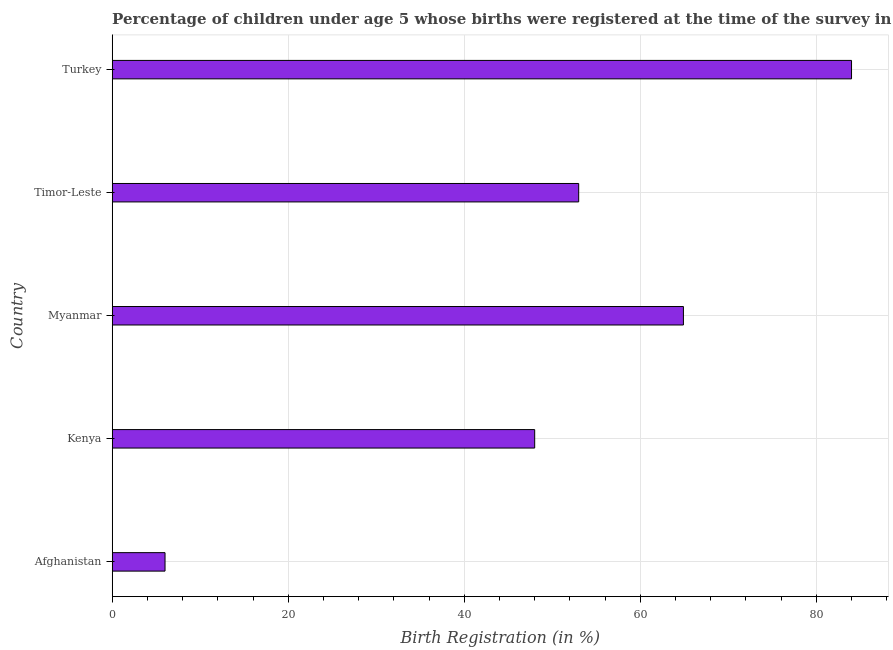Does the graph contain any zero values?
Keep it short and to the point. No. Does the graph contain grids?
Offer a terse response. Yes. What is the title of the graph?
Give a very brief answer. Percentage of children under age 5 whose births were registered at the time of the survey in 2003. What is the label or title of the X-axis?
Provide a short and direct response. Birth Registration (in %). What is the label or title of the Y-axis?
Provide a short and direct response. Country. What is the birth registration in Turkey?
Keep it short and to the point. 84. Across all countries, what is the minimum birth registration?
Provide a short and direct response. 6. In which country was the birth registration maximum?
Make the answer very short. Turkey. In which country was the birth registration minimum?
Your response must be concise. Afghanistan. What is the sum of the birth registration?
Offer a terse response. 255.9. What is the difference between the birth registration in Afghanistan and Myanmar?
Offer a terse response. -58.9. What is the average birth registration per country?
Make the answer very short. 51.18. What is the median birth registration?
Your answer should be compact. 53. What is the ratio of the birth registration in Kenya to that in Myanmar?
Your answer should be very brief. 0.74. Is the sum of the birth registration in Afghanistan and Timor-Leste greater than the maximum birth registration across all countries?
Your response must be concise. No. What is the difference between the highest and the lowest birth registration?
Give a very brief answer. 78. How many bars are there?
Make the answer very short. 5. What is the Birth Registration (in %) of Kenya?
Keep it short and to the point. 48. What is the Birth Registration (in %) of Myanmar?
Your answer should be compact. 64.9. What is the Birth Registration (in %) in Timor-Leste?
Ensure brevity in your answer.  53. What is the difference between the Birth Registration (in %) in Afghanistan and Kenya?
Offer a very short reply. -42. What is the difference between the Birth Registration (in %) in Afghanistan and Myanmar?
Offer a very short reply. -58.9. What is the difference between the Birth Registration (in %) in Afghanistan and Timor-Leste?
Offer a terse response. -47. What is the difference between the Birth Registration (in %) in Afghanistan and Turkey?
Offer a very short reply. -78. What is the difference between the Birth Registration (in %) in Kenya and Myanmar?
Offer a very short reply. -16.9. What is the difference between the Birth Registration (in %) in Kenya and Timor-Leste?
Your response must be concise. -5. What is the difference between the Birth Registration (in %) in Kenya and Turkey?
Your answer should be very brief. -36. What is the difference between the Birth Registration (in %) in Myanmar and Timor-Leste?
Provide a short and direct response. 11.9. What is the difference between the Birth Registration (in %) in Myanmar and Turkey?
Give a very brief answer. -19.1. What is the difference between the Birth Registration (in %) in Timor-Leste and Turkey?
Provide a short and direct response. -31. What is the ratio of the Birth Registration (in %) in Afghanistan to that in Myanmar?
Offer a very short reply. 0.09. What is the ratio of the Birth Registration (in %) in Afghanistan to that in Timor-Leste?
Your answer should be very brief. 0.11. What is the ratio of the Birth Registration (in %) in Afghanistan to that in Turkey?
Give a very brief answer. 0.07. What is the ratio of the Birth Registration (in %) in Kenya to that in Myanmar?
Provide a short and direct response. 0.74. What is the ratio of the Birth Registration (in %) in Kenya to that in Timor-Leste?
Provide a succinct answer. 0.91. What is the ratio of the Birth Registration (in %) in Kenya to that in Turkey?
Provide a succinct answer. 0.57. What is the ratio of the Birth Registration (in %) in Myanmar to that in Timor-Leste?
Provide a succinct answer. 1.23. What is the ratio of the Birth Registration (in %) in Myanmar to that in Turkey?
Provide a succinct answer. 0.77. What is the ratio of the Birth Registration (in %) in Timor-Leste to that in Turkey?
Offer a terse response. 0.63. 